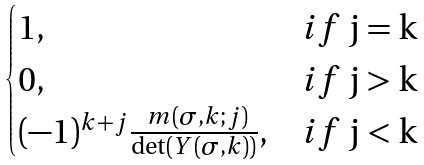<formula> <loc_0><loc_0><loc_500><loc_500>\begin{cases} 1 , & i f $ j = k $ \\ 0 , & i f $ j > k $ \\ ( - 1 ) ^ { k + j } \frac { \ m ( \sigma , k ; j ) } { \det ( Y ( \sigma , k ) ) } , & i f $ j < k $ \end{cases}</formula> 